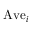<formula> <loc_0><loc_0><loc_500><loc_500>A v e _ { i }</formula> 